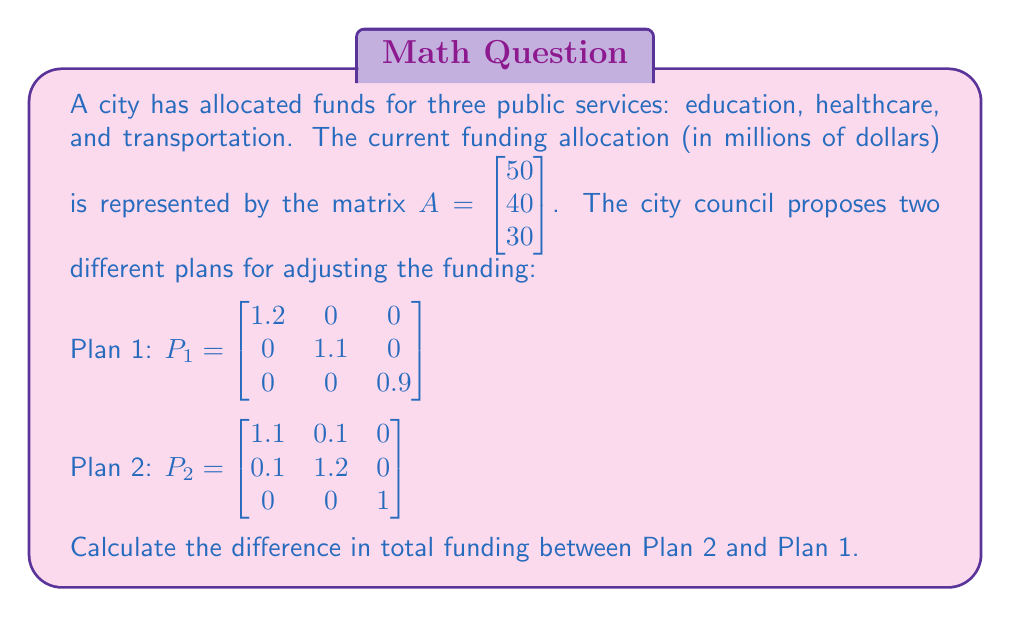Show me your answer to this math problem. Let's approach this step-by-step:

1) First, we need to calculate the new funding allocation for each plan by multiplying the plan matrix by the current allocation matrix.

   For Plan 1: 
   $$P_1A = \begin{bmatrix} 1.2 & 0 & 0 \\ 0 & 1.1 & 0 \\ 0 & 0 & 0.9 \end{bmatrix} \begin{bmatrix} 50 \\ 40 \\ 30 \end{bmatrix} = \begin{bmatrix} 60 \\ 44 \\ 27 \end{bmatrix}$$

   For Plan 2:
   $$P_2A = \begin{bmatrix} 1.1 & 0.1 & 0 \\ 0.1 & 1.2 & 0 \\ 0 & 0 & 1 \end{bmatrix} \begin{bmatrix} 50 \\ 40 \\ 30 \end{bmatrix} = \begin{bmatrix} 59 \\ 53 \\ 30 \end{bmatrix}$$

2) Now, we need to calculate the total funding for each plan by summing the elements of each resulting matrix.

   Total funding for Plan 1: $60 + 44 + 27 = 131$ million dollars
   Total funding for Plan 2: $59 + 53 + 30 = 142$ million dollars

3) Finally, we calculate the difference in total funding:

   Difference = Total funding Plan 2 - Total funding Plan 1
               = $142 - 131 = 11$ million dollars

Therefore, Plan 2 results in $11 million more in total funding compared to Plan 1.
Answer: $11 million 